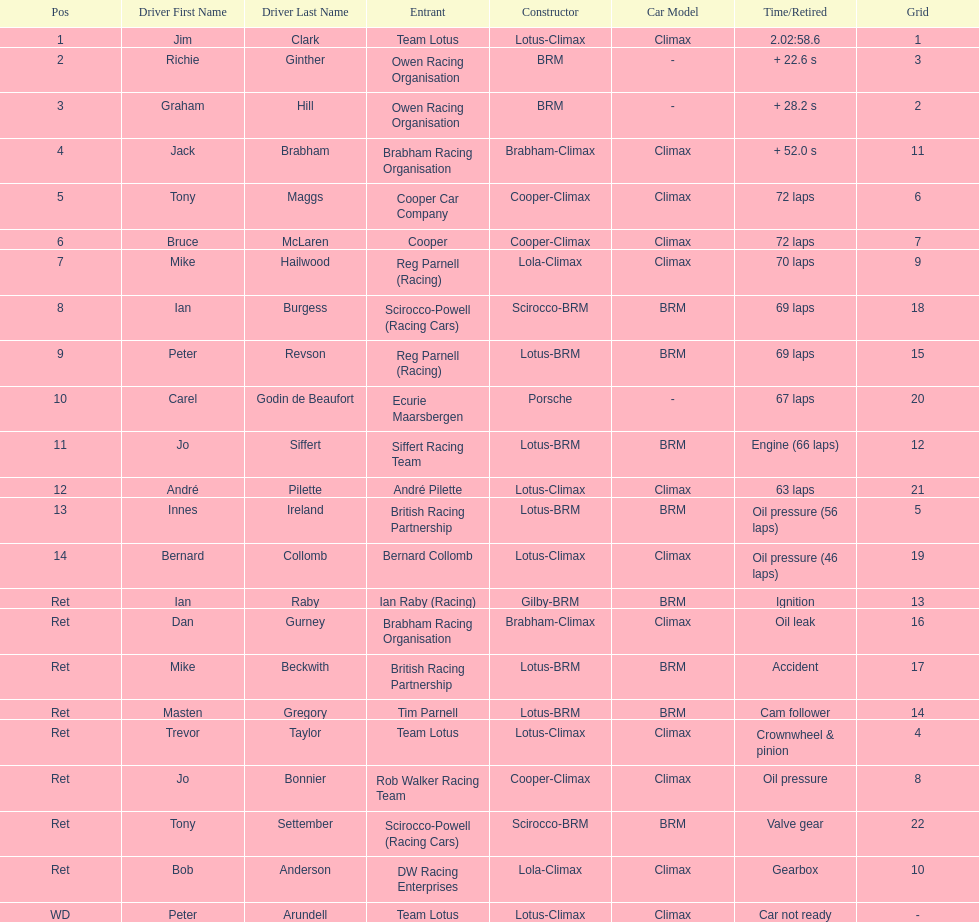Which driver did not have his/her car ready? Peter Arundell. 